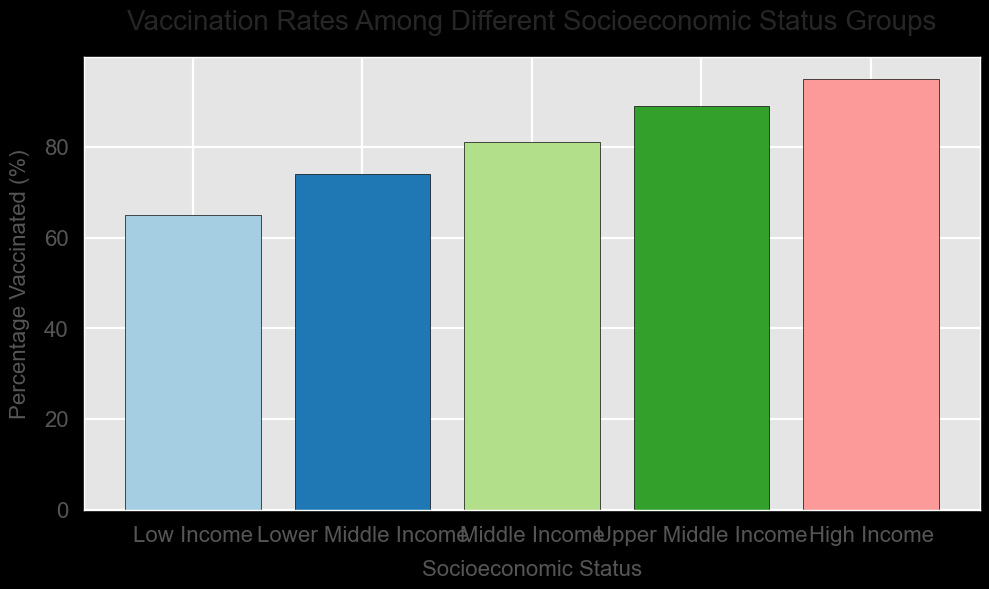What is the percentage difference in vaccination rates between Low Income and High Income groups? To find the percentage difference, subtract the percentage for Low Income (65%) from the percentage for High Income (95%). The difference is 95% - 65% = 30%.
Answer: 30% Which socioeconomic status group has the highest vaccination rate? The group with the highest bar length represents the highest vaccination rate. Here, the High Income group has the tallest bar.
Answer: High Income Which two consecutive groups have the smallest increase in vaccination rates? To find this, compare the differences in vaccination rates between consecutive groups: Lower Middle Income - Low Income (74% - 65% = 9%), Middle Income - Lower Middle Income (81% - 74% = 7%), Upper Middle Income - Middle Income (89% - 81% = 8%), and High Income - Upper Middle Income (95% - 89% = 6%). The smallest increase is between Upper Middle Income and High Income (6%).
Answer: Upper Middle Income and High Income Which group has a vaccination rate just above 80%? The group with a vaccination rate just above 80% is the one corresponding to the 81% bar. This group is Middle Income.
Answer: Middle Income How much higher is the vaccination rate of Upper Middle Income compared to Low Income? Subtract the percentage for Low Income (65%) from Upper Middle Income (89%). The difference is 89% - 65% = 24%.
Answer: 24% What is the total percentage vaccinated for all the groups combined? Sum the percentages of all groups: 65 (Low Income) + 74 (Lower Middle Income) + 81 (Middle Income) + 89 (Upper Middle Income) + 95 (High Income) = 404.
Answer: 404% Is the difference in vaccination rates between Lower Middle Income and Upper Middle Income greater than the difference between Middle Income and High Income? Calculate both differences: Lower Middle Income to Upper Middle Income is 89% - 74% = 15%, and Middle Income to High Income is 95% - 81% = 14%. 15% is greater than 14%.
Answer: Yes What is the average vaccination rate across all socioeconomic groups? Sum the percentages of all groups and divide by the number of groups. (65 + 74 + 81 + 89 + 95) / 5 = 404 / 5 = 80.8.
Answer: 80.8% Does the vaccination rate increase consistently across increasing socioeconomic status groups? Yes. By observing the bar heights from Low Income to High Income, each consecutive group has a higher percentage than the previous one.
Answer: Yes Which two groups have the closest vaccination rates? Compare the percentage differences between all consecutive groups: Low Income and Lower Middle Income (74% - 65% = 9%), Lower Middle Income and Middle Income (81% - 74% = 7%), Middle Income and Upper Middle Income (89% - 81% = 8%), and Upper Middle Income and High Income (95% - 89% = 6%). The closest rates are Upper Middle Income and High Income with a difference of 6%.
Answer: Upper Middle Income and High Income 